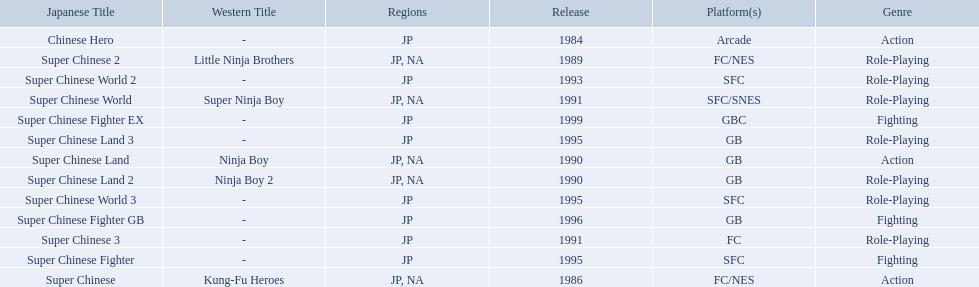Super ninja world was released in what countries? JP, NA. What was the original name for this title? Super Chinese World. 